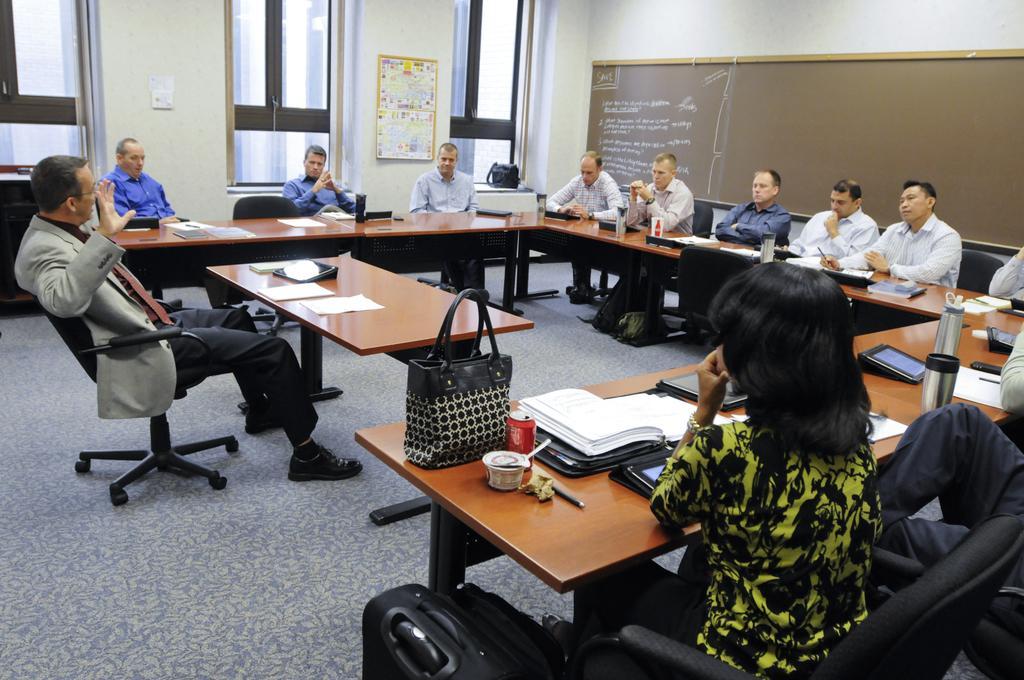Can you describe this image briefly? In this picture there are a group of people sitting in a square shape, this a man sitting here and raising his right hand, he has a table which has some papers kept on it, there is also a handbag, beverage can and pen placed on the table there are smartphones, there are some books extra kept on the table and there is a board in the back drop driver windows also 